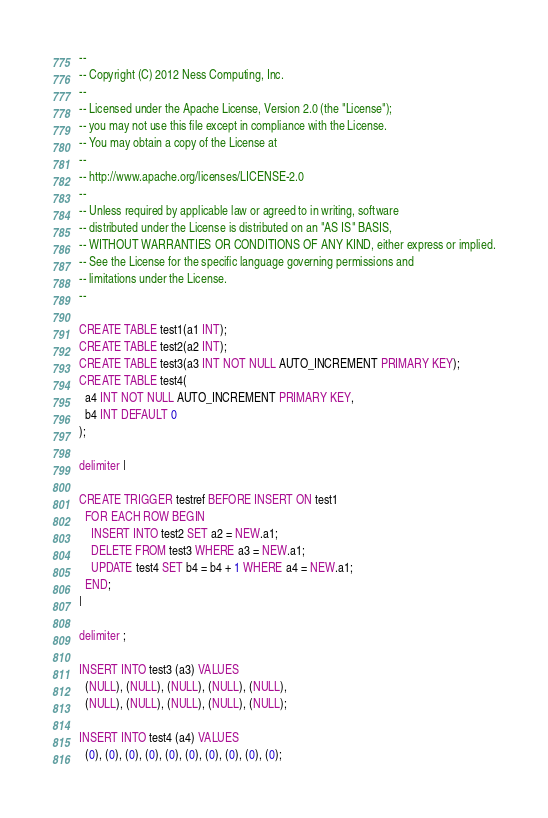Convert code to text. <code><loc_0><loc_0><loc_500><loc_500><_SQL_>--
-- Copyright (C) 2012 Ness Computing, Inc.
--
-- Licensed under the Apache License, Version 2.0 (the "License");
-- you may not use this file except in compliance with the License.
-- You may obtain a copy of the License at
--
-- http://www.apache.org/licenses/LICENSE-2.0
--
-- Unless required by applicable law or agreed to in writing, software
-- distributed under the License is distributed on an "AS IS" BASIS,
-- WITHOUT WARRANTIES OR CONDITIONS OF ANY KIND, either express or implied.
-- See the License for the specific language governing permissions and
-- limitations under the License.
--

CREATE TABLE test1(a1 INT);
CREATE TABLE test2(a2 INT);
CREATE TABLE test3(a3 INT NOT NULL AUTO_INCREMENT PRIMARY KEY);
CREATE TABLE test4(
  a4 INT NOT NULL AUTO_INCREMENT PRIMARY KEY,
  b4 INT DEFAULT 0
);

delimiter |

CREATE TRIGGER testref BEFORE INSERT ON test1
  FOR EACH ROW BEGIN
    INSERT INTO test2 SET a2 = NEW.a1;
    DELETE FROM test3 WHERE a3 = NEW.a1;
    UPDATE test4 SET b4 = b4 + 1 WHERE a4 = NEW.a1;
  END;
|

delimiter ;

INSERT INTO test3 (a3) VALUES
  (NULL), (NULL), (NULL), (NULL), (NULL),
  (NULL), (NULL), (NULL), (NULL), (NULL);

INSERT INTO test4 (a4) VALUES
  (0), (0), (0), (0), (0), (0), (0), (0), (0), (0);
</code> 